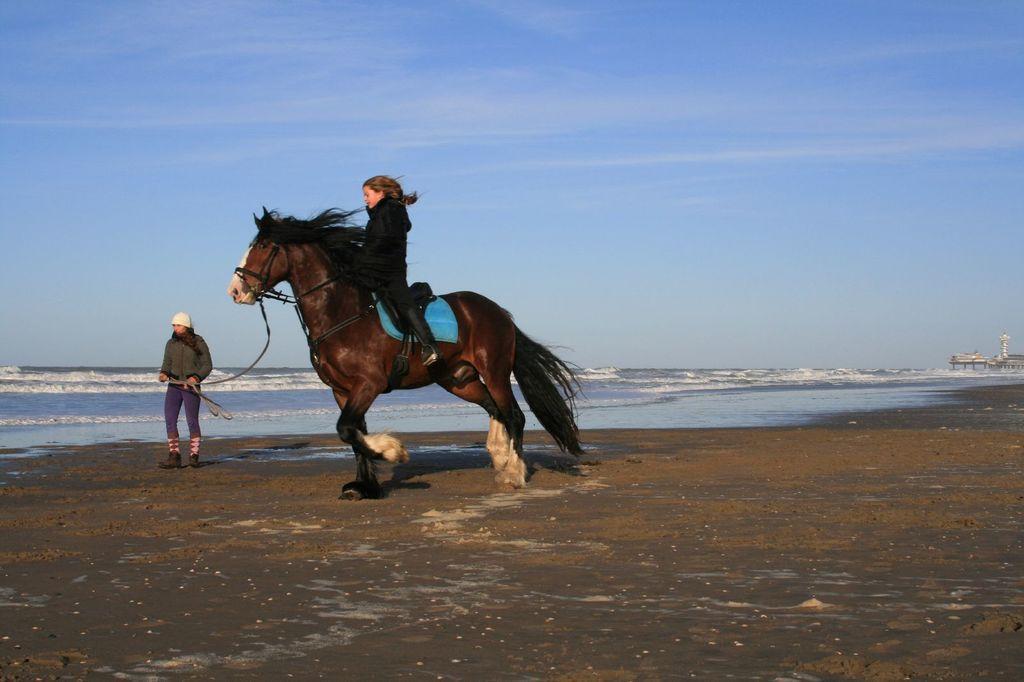Could you give a brief overview of what you see in this image? In this image we can see a girl riding the horse on the path, beside the horse there is a person standing and holding a rope of a horse. In the background there is a river and sky. 